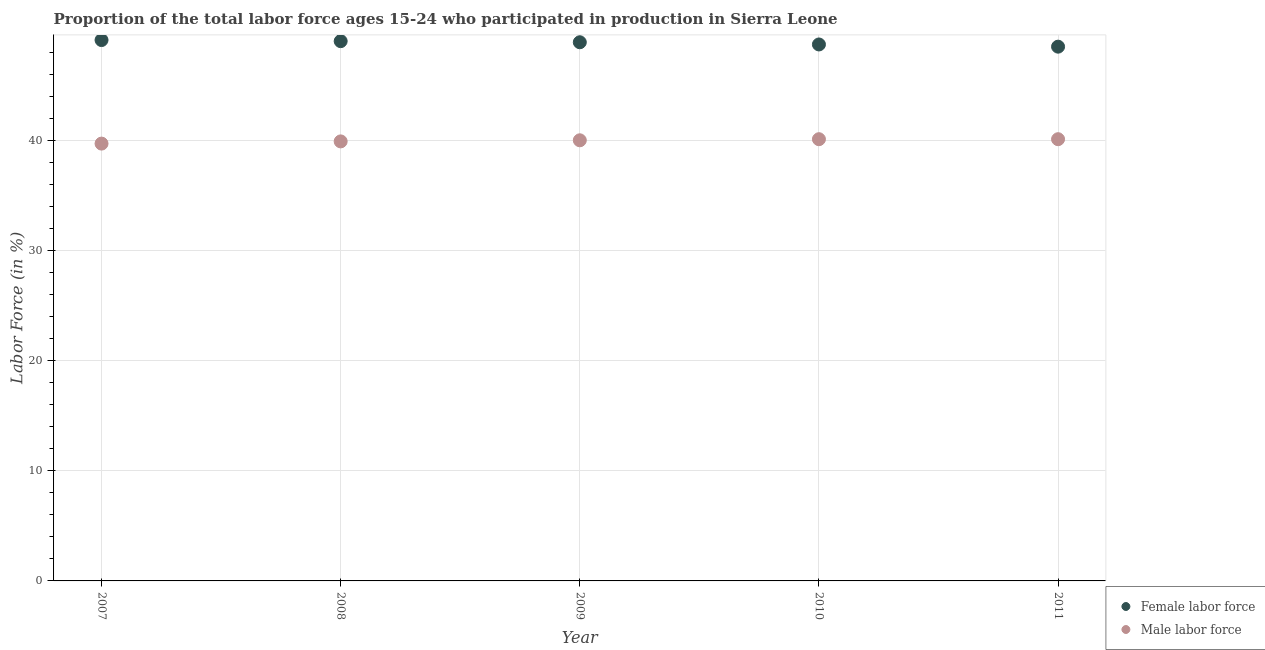How many different coloured dotlines are there?
Your answer should be compact. 2. What is the percentage of female labor force in 2007?
Provide a succinct answer. 49.1. Across all years, what is the maximum percentage of male labour force?
Your answer should be very brief. 40.1. Across all years, what is the minimum percentage of female labor force?
Your response must be concise. 48.5. What is the total percentage of female labor force in the graph?
Your answer should be compact. 244.2. What is the difference between the percentage of male labour force in 2007 and that in 2009?
Your response must be concise. -0.3. What is the difference between the percentage of female labor force in 2010 and the percentage of male labour force in 2008?
Ensure brevity in your answer.  8.8. What is the average percentage of female labor force per year?
Provide a short and direct response. 48.84. In the year 2010, what is the difference between the percentage of female labor force and percentage of male labour force?
Keep it short and to the point. 8.6. In how many years, is the percentage of male labour force greater than 4 %?
Make the answer very short. 5. What is the ratio of the percentage of female labor force in 2008 to that in 2011?
Offer a very short reply. 1.01. Is the difference between the percentage of male labour force in 2008 and 2010 greater than the difference between the percentage of female labor force in 2008 and 2010?
Provide a short and direct response. No. What is the difference between the highest and the second highest percentage of female labor force?
Give a very brief answer. 0.1. What is the difference between the highest and the lowest percentage of male labour force?
Give a very brief answer. 0.4. Is the sum of the percentage of female labor force in 2007 and 2009 greater than the maximum percentage of male labour force across all years?
Your answer should be compact. Yes. Is the percentage of male labour force strictly greater than the percentage of female labor force over the years?
Your answer should be compact. No. Is the percentage of female labor force strictly less than the percentage of male labour force over the years?
Give a very brief answer. No. How many dotlines are there?
Provide a short and direct response. 2. Does the graph contain any zero values?
Offer a terse response. No. Where does the legend appear in the graph?
Your answer should be very brief. Bottom right. How many legend labels are there?
Make the answer very short. 2. What is the title of the graph?
Your response must be concise. Proportion of the total labor force ages 15-24 who participated in production in Sierra Leone. What is the label or title of the X-axis?
Make the answer very short. Year. What is the Labor Force (in %) of Female labor force in 2007?
Your response must be concise. 49.1. What is the Labor Force (in %) of Male labor force in 2007?
Ensure brevity in your answer.  39.7. What is the Labor Force (in %) in Female labor force in 2008?
Keep it short and to the point. 49. What is the Labor Force (in %) in Male labor force in 2008?
Keep it short and to the point. 39.9. What is the Labor Force (in %) in Female labor force in 2009?
Give a very brief answer. 48.9. What is the Labor Force (in %) in Female labor force in 2010?
Keep it short and to the point. 48.7. What is the Labor Force (in %) of Male labor force in 2010?
Provide a succinct answer. 40.1. What is the Labor Force (in %) in Female labor force in 2011?
Offer a terse response. 48.5. What is the Labor Force (in %) in Male labor force in 2011?
Offer a terse response. 40.1. Across all years, what is the maximum Labor Force (in %) of Female labor force?
Provide a short and direct response. 49.1. Across all years, what is the maximum Labor Force (in %) of Male labor force?
Your response must be concise. 40.1. Across all years, what is the minimum Labor Force (in %) in Female labor force?
Offer a very short reply. 48.5. Across all years, what is the minimum Labor Force (in %) in Male labor force?
Make the answer very short. 39.7. What is the total Labor Force (in %) of Female labor force in the graph?
Offer a terse response. 244.2. What is the total Labor Force (in %) in Male labor force in the graph?
Your answer should be very brief. 199.8. What is the difference between the Labor Force (in %) of Female labor force in 2007 and that in 2009?
Ensure brevity in your answer.  0.2. What is the difference between the Labor Force (in %) in Female labor force in 2007 and that in 2010?
Make the answer very short. 0.4. What is the difference between the Labor Force (in %) of Male labor force in 2007 and that in 2011?
Offer a terse response. -0.4. What is the difference between the Labor Force (in %) of Female labor force in 2008 and that in 2009?
Your response must be concise. 0.1. What is the difference between the Labor Force (in %) of Female labor force in 2008 and that in 2011?
Your answer should be compact. 0.5. What is the difference between the Labor Force (in %) in Male labor force in 2008 and that in 2011?
Ensure brevity in your answer.  -0.2. What is the difference between the Labor Force (in %) in Male labor force in 2009 and that in 2010?
Give a very brief answer. -0.1. What is the difference between the Labor Force (in %) in Male labor force in 2009 and that in 2011?
Ensure brevity in your answer.  -0.1. What is the difference between the Labor Force (in %) in Female labor force in 2007 and the Labor Force (in %) in Male labor force in 2009?
Your response must be concise. 9.1. What is the difference between the Labor Force (in %) of Female labor force in 2008 and the Labor Force (in %) of Male labor force in 2009?
Your answer should be compact. 9. What is the difference between the Labor Force (in %) of Female labor force in 2008 and the Labor Force (in %) of Male labor force in 2010?
Make the answer very short. 8.9. What is the difference between the Labor Force (in %) in Female labor force in 2008 and the Labor Force (in %) in Male labor force in 2011?
Offer a very short reply. 8.9. What is the difference between the Labor Force (in %) in Female labor force in 2009 and the Labor Force (in %) in Male labor force in 2011?
Your answer should be very brief. 8.8. What is the difference between the Labor Force (in %) of Female labor force in 2010 and the Labor Force (in %) of Male labor force in 2011?
Ensure brevity in your answer.  8.6. What is the average Labor Force (in %) of Female labor force per year?
Keep it short and to the point. 48.84. What is the average Labor Force (in %) of Male labor force per year?
Give a very brief answer. 39.96. In the year 2007, what is the difference between the Labor Force (in %) in Female labor force and Labor Force (in %) in Male labor force?
Make the answer very short. 9.4. In the year 2008, what is the difference between the Labor Force (in %) in Female labor force and Labor Force (in %) in Male labor force?
Keep it short and to the point. 9.1. In the year 2010, what is the difference between the Labor Force (in %) in Female labor force and Labor Force (in %) in Male labor force?
Provide a short and direct response. 8.6. In the year 2011, what is the difference between the Labor Force (in %) of Female labor force and Labor Force (in %) of Male labor force?
Your response must be concise. 8.4. What is the ratio of the Labor Force (in %) of Female labor force in 2007 to that in 2008?
Provide a short and direct response. 1. What is the ratio of the Labor Force (in %) of Male labor force in 2007 to that in 2008?
Provide a succinct answer. 0.99. What is the ratio of the Labor Force (in %) in Female labor force in 2007 to that in 2009?
Your response must be concise. 1. What is the ratio of the Labor Force (in %) in Male labor force in 2007 to that in 2009?
Give a very brief answer. 0.99. What is the ratio of the Labor Force (in %) of Female labor force in 2007 to that in 2010?
Give a very brief answer. 1.01. What is the ratio of the Labor Force (in %) of Male labor force in 2007 to that in 2010?
Keep it short and to the point. 0.99. What is the ratio of the Labor Force (in %) of Female labor force in 2007 to that in 2011?
Your answer should be very brief. 1.01. What is the ratio of the Labor Force (in %) of Male labor force in 2007 to that in 2011?
Provide a succinct answer. 0.99. What is the ratio of the Labor Force (in %) of Female labor force in 2008 to that in 2009?
Give a very brief answer. 1. What is the ratio of the Labor Force (in %) in Female labor force in 2008 to that in 2011?
Ensure brevity in your answer.  1.01. What is the ratio of the Labor Force (in %) in Female labor force in 2009 to that in 2011?
Offer a very short reply. 1.01. What is the ratio of the Labor Force (in %) of Male labor force in 2009 to that in 2011?
Offer a terse response. 1. What is the ratio of the Labor Force (in %) in Female labor force in 2010 to that in 2011?
Your answer should be compact. 1. What is the difference between the highest and the second highest Labor Force (in %) of Male labor force?
Your answer should be very brief. 0. What is the difference between the highest and the lowest Labor Force (in %) of Female labor force?
Keep it short and to the point. 0.6. What is the difference between the highest and the lowest Labor Force (in %) in Male labor force?
Your answer should be very brief. 0.4. 